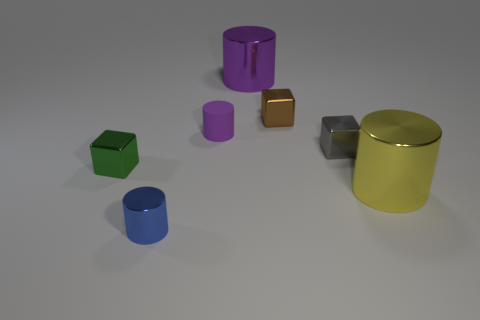Subtract all gray cylinders. Subtract all blue blocks. How many cylinders are left? 4 Add 3 tiny blue cylinders. How many objects exist? 10 Subtract all blocks. How many objects are left? 4 Add 4 purple metallic cylinders. How many purple metallic cylinders are left? 5 Add 5 large things. How many large things exist? 7 Subtract 0 green cylinders. How many objects are left? 7 Subtract all large blue objects. Subtract all brown things. How many objects are left? 6 